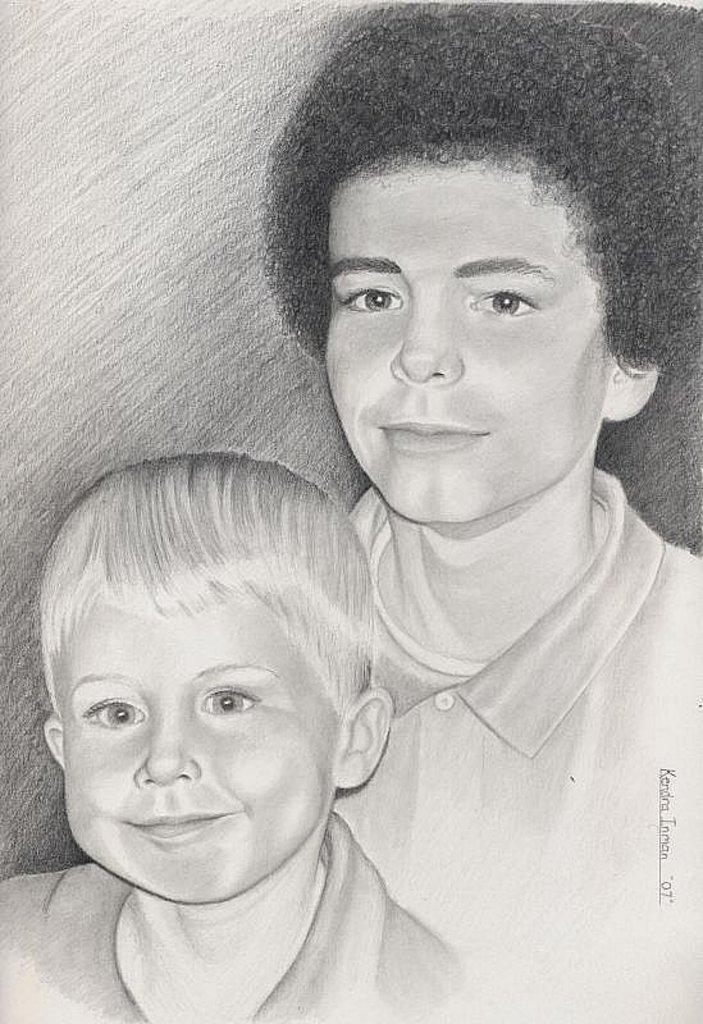What type of artwork is featured in the image? The image contains a pencil sketch. What subjects are depicted in the sketch? The sketch depicts a man and a boy. Can you describe the appearance of the man in the sketch? The man has curly hair. What type of tramp is visible in the image? There is no tramp present in the image; it features a pencil sketch of a man and a boy. How many units are visible in the image? The image does not contain any units; it is a pencil sketch of a man and a boy. 